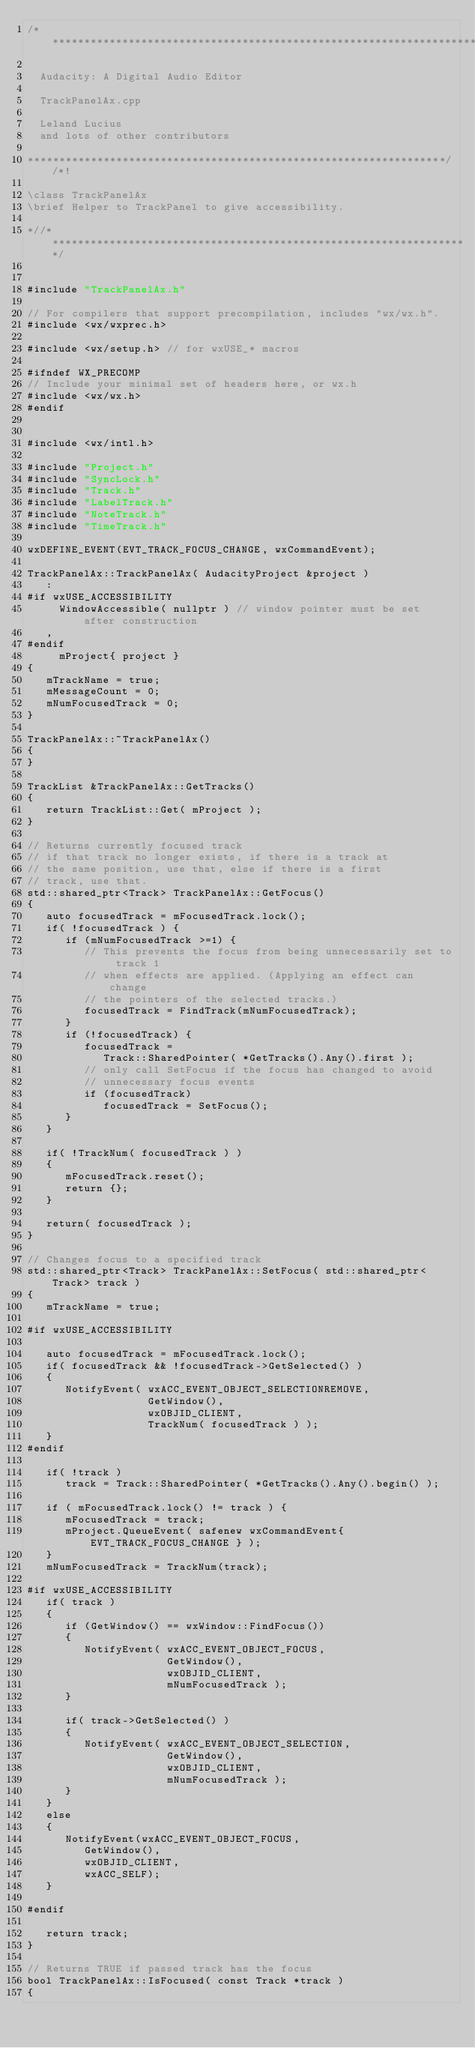<code> <loc_0><loc_0><loc_500><loc_500><_C++_>/**********************************************************************

  Audacity: A Digital Audio Editor

  TrackPanelAx.cpp

  Leland Lucius
  and lots of other contributors

******************************************************************//*!

\class TrackPanelAx
\brief Helper to TrackPanel to give accessibility.

*//*******************************************************************/


#include "TrackPanelAx.h"

// For compilers that support precompilation, includes "wx/wx.h".
#include <wx/wxprec.h>

#include <wx/setup.h> // for wxUSE_* macros

#ifndef WX_PRECOMP
// Include your minimal set of headers here, or wx.h
#include <wx/wx.h>
#endif


#include <wx/intl.h>

#include "Project.h"
#include "SyncLock.h"
#include "Track.h"
#include "LabelTrack.h"
#include "NoteTrack.h"
#include "TimeTrack.h"

wxDEFINE_EVENT(EVT_TRACK_FOCUS_CHANGE, wxCommandEvent);

TrackPanelAx::TrackPanelAx( AudacityProject &project )
   :
#if wxUSE_ACCESSIBILITY
     WindowAccessible( nullptr ) // window pointer must be set after construction
   ,
#endif
     mProject{ project }
{
   mTrackName = true;
   mMessageCount = 0;
   mNumFocusedTrack = 0;
}

TrackPanelAx::~TrackPanelAx()
{
}

TrackList &TrackPanelAx::GetTracks()
{
   return TrackList::Get( mProject );
}

// Returns currently focused track
// if that track no longer exists, if there is a track at
// the same position, use that, else if there is a first
// track, use that.
std::shared_ptr<Track> TrackPanelAx::GetFocus()
{
   auto focusedTrack = mFocusedTrack.lock();
   if( !focusedTrack ) {
      if (mNumFocusedTrack >=1) {
         // This prevents the focus from being unnecessarily set to track 1
         // when effects are applied. (Applying an effect can change
         // the pointers of the selected tracks.)
         focusedTrack = FindTrack(mNumFocusedTrack);
      }
      if (!focusedTrack) {
         focusedTrack =
            Track::SharedPointer( *GetTracks().Any().first );
         // only call SetFocus if the focus has changed to avoid
         // unnecessary focus events
         if (focusedTrack) 
            focusedTrack = SetFocus();
      }
   }

   if( !TrackNum( focusedTrack ) )
   {
      mFocusedTrack.reset();
      return {};
   }

   return( focusedTrack );
}

// Changes focus to a specified track
std::shared_ptr<Track> TrackPanelAx::SetFocus( std::shared_ptr<Track> track )
{
   mTrackName = true;

#if wxUSE_ACCESSIBILITY

   auto focusedTrack = mFocusedTrack.lock();
   if( focusedTrack && !focusedTrack->GetSelected() )
   {
      NotifyEvent( wxACC_EVENT_OBJECT_SELECTIONREMOVE,
                   GetWindow(),
                   wxOBJID_CLIENT,
                   TrackNum( focusedTrack ) );
   }
#endif

   if( !track )
      track = Track::SharedPointer( *GetTracks().Any().begin() );

   if ( mFocusedTrack.lock() != track ) {
      mFocusedTrack = track;
      mProject.QueueEvent( safenew wxCommandEvent{ EVT_TRACK_FOCUS_CHANGE } );
   }
   mNumFocusedTrack = TrackNum(track);

#if wxUSE_ACCESSIBILITY
   if( track )
   {
      if (GetWindow() == wxWindow::FindFocus())
      {
         NotifyEvent( wxACC_EVENT_OBJECT_FOCUS,
                      GetWindow(),
                      wxOBJID_CLIENT,
                      mNumFocusedTrack );
      }

      if( track->GetSelected() )
      {
         NotifyEvent( wxACC_EVENT_OBJECT_SELECTION,
                      GetWindow(),
                      wxOBJID_CLIENT,
                      mNumFocusedTrack );
      }
   }
   else
   {
      NotifyEvent(wxACC_EVENT_OBJECT_FOCUS,
         GetWindow(),
         wxOBJID_CLIENT,
         wxACC_SELF);
   }

#endif

   return track;
}

// Returns TRUE if passed track has the focus
bool TrackPanelAx::IsFocused( const Track *track )
{</code> 